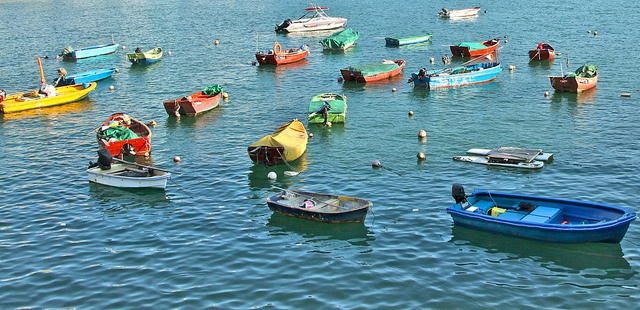Describe the objects in this image and their specific colors. I can see boat in darkgray, navy, black, and blue tones, boat in darkgray, teal, ivory, black, and turquoise tones, boat in darkgray, black, and gray tones, boat in darkgray, lightgray, and lightblue tones, and boat in darkgray, black, khaki, and olive tones in this image. 